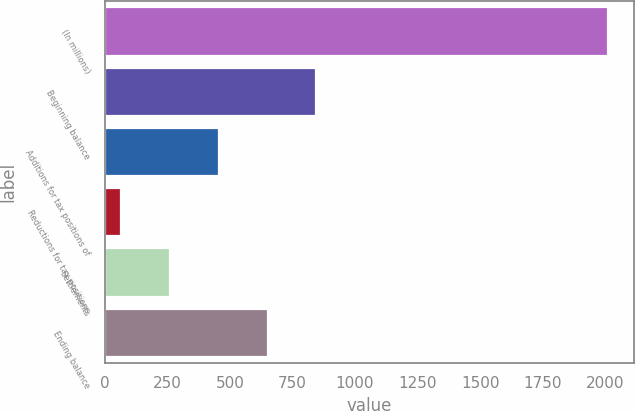<chart> <loc_0><loc_0><loc_500><loc_500><bar_chart><fcel>(In millions)<fcel>Beginning balance<fcel>Additions for tax positions of<fcel>Reductions for tax positions<fcel>Settlements<fcel>Ending balance<nl><fcel>2012<fcel>845<fcel>456<fcel>67<fcel>261.5<fcel>650.5<nl></chart> 